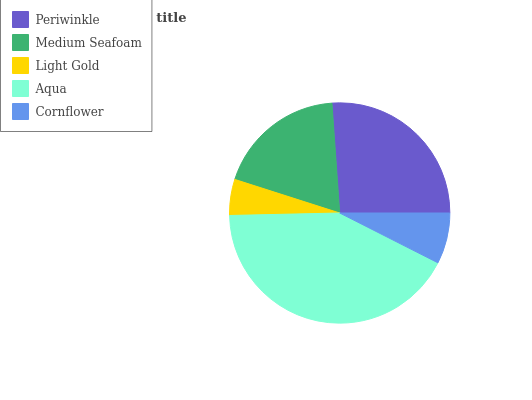Is Light Gold the minimum?
Answer yes or no. Yes. Is Aqua the maximum?
Answer yes or no. Yes. Is Medium Seafoam the minimum?
Answer yes or no. No. Is Medium Seafoam the maximum?
Answer yes or no. No. Is Periwinkle greater than Medium Seafoam?
Answer yes or no. Yes. Is Medium Seafoam less than Periwinkle?
Answer yes or no. Yes. Is Medium Seafoam greater than Periwinkle?
Answer yes or no. No. Is Periwinkle less than Medium Seafoam?
Answer yes or no. No. Is Medium Seafoam the high median?
Answer yes or no. Yes. Is Medium Seafoam the low median?
Answer yes or no. Yes. Is Aqua the high median?
Answer yes or no. No. Is Aqua the low median?
Answer yes or no. No. 